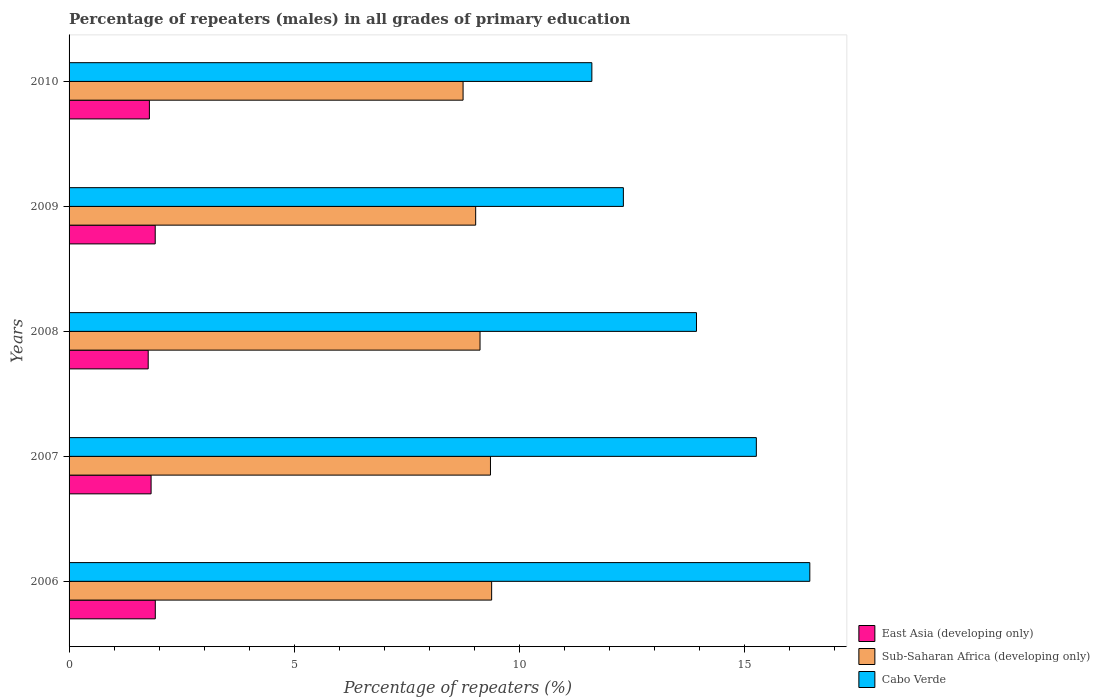How many different coloured bars are there?
Offer a very short reply. 3. How many groups of bars are there?
Your answer should be compact. 5. Are the number of bars per tick equal to the number of legend labels?
Make the answer very short. Yes. Are the number of bars on each tick of the Y-axis equal?
Give a very brief answer. Yes. How many bars are there on the 3rd tick from the top?
Give a very brief answer. 3. What is the percentage of repeaters (males) in Cabo Verde in 2009?
Provide a succinct answer. 12.31. Across all years, what is the maximum percentage of repeaters (males) in Sub-Saharan Africa (developing only)?
Keep it short and to the point. 9.38. Across all years, what is the minimum percentage of repeaters (males) in Sub-Saharan Africa (developing only)?
Give a very brief answer. 8.75. In which year was the percentage of repeaters (males) in Cabo Verde minimum?
Offer a terse response. 2010. What is the total percentage of repeaters (males) in East Asia (developing only) in the graph?
Offer a very short reply. 9.19. What is the difference between the percentage of repeaters (males) in Sub-Saharan Africa (developing only) in 2006 and that in 2007?
Ensure brevity in your answer.  0.03. What is the difference between the percentage of repeaters (males) in Sub-Saharan Africa (developing only) in 2006 and the percentage of repeaters (males) in Cabo Verde in 2007?
Your answer should be compact. -5.88. What is the average percentage of repeaters (males) in East Asia (developing only) per year?
Give a very brief answer. 1.84. In the year 2008, what is the difference between the percentage of repeaters (males) in East Asia (developing only) and percentage of repeaters (males) in Sub-Saharan Africa (developing only)?
Give a very brief answer. -7.37. What is the ratio of the percentage of repeaters (males) in Sub-Saharan Africa (developing only) in 2007 to that in 2008?
Provide a succinct answer. 1.03. Is the difference between the percentage of repeaters (males) in East Asia (developing only) in 2009 and 2010 greater than the difference between the percentage of repeaters (males) in Sub-Saharan Africa (developing only) in 2009 and 2010?
Your answer should be compact. No. What is the difference between the highest and the second highest percentage of repeaters (males) in Cabo Verde?
Your answer should be very brief. 1.19. What is the difference between the highest and the lowest percentage of repeaters (males) in Sub-Saharan Africa (developing only)?
Offer a terse response. 0.63. What does the 2nd bar from the top in 2010 represents?
Keep it short and to the point. Sub-Saharan Africa (developing only). What does the 2nd bar from the bottom in 2007 represents?
Your answer should be very brief. Sub-Saharan Africa (developing only). Are all the bars in the graph horizontal?
Offer a very short reply. Yes. What is the difference between two consecutive major ticks on the X-axis?
Offer a very short reply. 5. Does the graph contain any zero values?
Provide a short and direct response. No. Does the graph contain grids?
Keep it short and to the point. No. Where does the legend appear in the graph?
Offer a terse response. Bottom right. How are the legend labels stacked?
Offer a very short reply. Vertical. What is the title of the graph?
Provide a short and direct response. Percentage of repeaters (males) in all grades of primary education. What is the label or title of the X-axis?
Keep it short and to the point. Percentage of repeaters (%). What is the Percentage of repeaters (%) in East Asia (developing only) in 2006?
Provide a short and direct response. 1.91. What is the Percentage of repeaters (%) in Sub-Saharan Africa (developing only) in 2006?
Ensure brevity in your answer.  9.38. What is the Percentage of repeaters (%) of Cabo Verde in 2006?
Keep it short and to the point. 16.45. What is the Percentage of repeaters (%) of East Asia (developing only) in 2007?
Offer a terse response. 1.82. What is the Percentage of repeaters (%) of Sub-Saharan Africa (developing only) in 2007?
Your answer should be very brief. 9.36. What is the Percentage of repeaters (%) of Cabo Verde in 2007?
Give a very brief answer. 15.26. What is the Percentage of repeaters (%) of East Asia (developing only) in 2008?
Your answer should be very brief. 1.76. What is the Percentage of repeaters (%) in Sub-Saharan Africa (developing only) in 2008?
Provide a succinct answer. 9.12. What is the Percentage of repeaters (%) in Cabo Verde in 2008?
Provide a short and direct response. 13.93. What is the Percentage of repeaters (%) in East Asia (developing only) in 2009?
Offer a terse response. 1.91. What is the Percentage of repeaters (%) in Sub-Saharan Africa (developing only) in 2009?
Provide a succinct answer. 9.03. What is the Percentage of repeaters (%) of Cabo Verde in 2009?
Offer a terse response. 12.31. What is the Percentage of repeaters (%) of East Asia (developing only) in 2010?
Give a very brief answer. 1.78. What is the Percentage of repeaters (%) of Sub-Saharan Africa (developing only) in 2010?
Offer a very short reply. 8.75. What is the Percentage of repeaters (%) of Cabo Verde in 2010?
Offer a terse response. 11.61. Across all years, what is the maximum Percentage of repeaters (%) in East Asia (developing only)?
Your answer should be very brief. 1.91. Across all years, what is the maximum Percentage of repeaters (%) in Sub-Saharan Africa (developing only)?
Give a very brief answer. 9.38. Across all years, what is the maximum Percentage of repeaters (%) of Cabo Verde?
Provide a short and direct response. 16.45. Across all years, what is the minimum Percentage of repeaters (%) in East Asia (developing only)?
Provide a succinct answer. 1.76. Across all years, what is the minimum Percentage of repeaters (%) in Sub-Saharan Africa (developing only)?
Your answer should be compact. 8.75. Across all years, what is the minimum Percentage of repeaters (%) of Cabo Verde?
Your answer should be compact. 11.61. What is the total Percentage of repeaters (%) in East Asia (developing only) in the graph?
Offer a terse response. 9.19. What is the total Percentage of repeaters (%) in Sub-Saharan Africa (developing only) in the graph?
Your response must be concise. 45.64. What is the total Percentage of repeaters (%) of Cabo Verde in the graph?
Your response must be concise. 69.55. What is the difference between the Percentage of repeaters (%) of East Asia (developing only) in 2006 and that in 2007?
Offer a terse response. 0.09. What is the difference between the Percentage of repeaters (%) in Sub-Saharan Africa (developing only) in 2006 and that in 2007?
Offer a very short reply. 0.03. What is the difference between the Percentage of repeaters (%) in Cabo Verde in 2006 and that in 2007?
Make the answer very short. 1.19. What is the difference between the Percentage of repeaters (%) of East Asia (developing only) in 2006 and that in 2008?
Your answer should be very brief. 0.16. What is the difference between the Percentage of repeaters (%) in Sub-Saharan Africa (developing only) in 2006 and that in 2008?
Ensure brevity in your answer.  0.26. What is the difference between the Percentage of repeaters (%) of Cabo Verde in 2006 and that in 2008?
Make the answer very short. 2.52. What is the difference between the Percentage of repeaters (%) of East Asia (developing only) in 2006 and that in 2009?
Provide a short and direct response. 0. What is the difference between the Percentage of repeaters (%) in Sub-Saharan Africa (developing only) in 2006 and that in 2009?
Keep it short and to the point. 0.35. What is the difference between the Percentage of repeaters (%) of Cabo Verde in 2006 and that in 2009?
Offer a very short reply. 4.14. What is the difference between the Percentage of repeaters (%) in East Asia (developing only) in 2006 and that in 2010?
Provide a short and direct response. 0.13. What is the difference between the Percentage of repeaters (%) in Sub-Saharan Africa (developing only) in 2006 and that in 2010?
Keep it short and to the point. 0.63. What is the difference between the Percentage of repeaters (%) of Cabo Verde in 2006 and that in 2010?
Offer a very short reply. 4.84. What is the difference between the Percentage of repeaters (%) in East Asia (developing only) in 2007 and that in 2008?
Ensure brevity in your answer.  0.06. What is the difference between the Percentage of repeaters (%) of Sub-Saharan Africa (developing only) in 2007 and that in 2008?
Your answer should be very brief. 0.23. What is the difference between the Percentage of repeaters (%) of Cabo Verde in 2007 and that in 2008?
Keep it short and to the point. 1.33. What is the difference between the Percentage of repeaters (%) in East Asia (developing only) in 2007 and that in 2009?
Make the answer very short. -0.09. What is the difference between the Percentage of repeaters (%) in Sub-Saharan Africa (developing only) in 2007 and that in 2009?
Your answer should be very brief. 0.33. What is the difference between the Percentage of repeaters (%) of Cabo Verde in 2007 and that in 2009?
Your answer should be compact. 2.95. What is the difference between the Percentage of repeaters (%) of East Asia (developing only) in 2007 and that in 2010?
Your answer should be compact. 0.04. What is the difference between the Percentage of repeaters (%) of Sub-Saharan Africa (developing only) in 2007 and that in 2010?
Give a very brief answer. 0.61. What is the difference between the Percentage of repeaters (%) of Cabo Verde in 2007 and that in 2010?
Your response must be concise. 3.65. What is the difference between the Percentage of repeaters (%) of East Asia (developing only) in 2008 and that in 2009?
Give a very brief answer. -0.16. What is the difference between the Percentage of repeaters (%) of Sub-Saharan Africa (developing only) in 2008 and that in 2009?
Keep it short and to the point. 0.1. What is the difference between the Percentage of repeaters (%) of Cabo Verde in 2008 and that in 2009?
Ensure brevity in your answer.  1.62. What is the difference between the Percentage of repeaters (%) in East Asia (developing only) in 2008 and that in 2010?
Give a very brief answer. -0.03. What is the difference between the Percentage of repeaters (%) in Sub-Saharan Africa (developing only) in 2008 and that in 2010?
Offer a very short reply. 0.38. What is the difference between the Percentage of repeaters (%) in Cabo Verde in 2008 and that in 2010?
Offer a very short reply. 2.32. What is the difference between the Percentage of repeaters (%) of East Asia (developing only) in 2009 and that in 2010?
Your answer should be very brief. 0.13. What is the difference between the Percentage of repeaters (%) of Sub-Saharan Africa (developing only) in 2009 and that in 2010?
Offer a very short reply. 0.28. What is the difference between the Percentage of repeaters (%) of Cabo Verde in 2009 and that in 2010?
Your answer should be very brief. 0.7. What is the difference between the Percentage of repeaters (%) of East Asia (developing only) in 2006 and the Percentage of repeaters (%) of Sub-Saharan Africa (developing only) in 2007?
Offer a terse response. -7.44. What is the difference between the Percentage of repeaters (%) in East Asia (developing only) in 2006 and the Percentage of repeaters (%) in Cabo Verde in 2007?
Offer a terse response. -13.34. What is the difference between the Percentage of repeaters (%) in Sub-Saharan Africa (developing only) in 2006 and the Percentage of repeaters (%) in Cabo Verde in 2007?
Make the answer very short. -5.88. What is the difference between the Percentage of repeaters (%) of East Asia (developing only) in 2006 and the Percentage of repeaters (%) of Sub-Saharan Africa (developing only) in 2008?
Ensure brevity in your answer.  -7.21. What is the difference between the Percentage of repeaters (%) of East Asia (developing only) in 2006 and the Percentage of repeaters (%) of Cabo Verde in 2008?
Offer a terse response. -12.02. What is the difference between the Percentage of repeaters (%) in Sub-Saharan Africa (developing only) in 2006 and the Percentage of repeaters (%) in Cabo Verde in 2008?
Provide a short and direct response. -4.55. What is the difference between the Percentage of repeaters (%) of East Asia (developing only) in 2006 and the Percentage of repeaters (%) of Sub-Saharan Africa (developing only) in 2009?
Your response must be concise. -7.11. What is the difference between the Percentage of repeaters (%) in East Asia (developing only) in 2006 and the Percentage of repeaters (%) in Cabo Verde in 2009?
Offer a very short reply. -10.39. What is the difference between the Percentage of repeaters (%) of Sub-Saharan Africa (developing only) in 2006 and the Percentage of repeaters (%) of Cabo Verde in 2009?
Your answer should be very brief. -2.92. What is the difference between the Percentage of repeaters (%) in East Asia (developing only) in 2006 and the Percentage of repeaters (%) in Sub-Saharan Africa (developing only) in 2010?
Your answer should be very brief. -6.83. What is the difference between the Percentage of repeaters (%) in East Asia (developing only) in 2006 and the Percentage of repeaters (%) in Cabo Verde in 2010?
Give a very brief answer. -9.69. What is the difference between the Percentage of repeaters (%) of Sub-Saharan Africa (developing only) in 2006 and the Percentage of repeaters (%) of Cabo Verde in 2010?
Offer a terse response. -2.23. What is the difference between the Percentage of repeaters (%) in East Asia (developing only) in 2007 and the Percentage of repeaters (%) in Sub-Saharan Africa (developing only) in 2008?
Provide a succinct answer. -7.3. What is the difference between the Percentage of repeaters (%) of East Asia (developing only) in 2007 and the Percentage of repeaters (%) of Cabo Verde in 2008?
Make the answer very short. -12.11. What is the difference between the Percentage of repeaters (%) in Sub-Saharan Africa (developing only) in 2007 and the Percentage of repeaters (%) in Cabo Verde in 2008?
Provide a short and direct response. -4.57. What is the difference between the Percentage of repeaters (%) in East Asia (developing only) in 2007 and the Percentage of repeaters (%) in Sub-Saharan Africa (developing only) in 2009?
Your answer should be compact. -7.21. What is the difference between the Percentage of repeaters (%) in East Asia (developing only) in 2007 and the Percentage of repeaters (%) in Cabo Verde in 2009?
Make the answer very short. -10.49. What is the difference between the Percentage of repeaters (%) in Sub-Saharan Africa (developing only) in 2007 and the Percentage of repeaters (%) in Cabo Verde in 2009?
Give a very brief answer. -2.95. What is the difference between the Percentage of repeaters (%) of East Asia (developing only) in 2007 and the Percentage of repeaters (%) of Sub-Saharan Africa (developing only) in 2010?
Keep it short and to the point. -6.93. What is the difference between the Percentage of repeaters (%) of East Asia (developing only) in 2007 and the Percentage of repeaters (%) of Cabo Verde in 2010?
Offer a very short reply. -9.79. What is the difference between the Percentage of repeaters (%) of Sub-Saharan Africa (developing only) in 2007 and the Percentage of repeaters (%) of Cabo Verde in 2010?
Provide a short and direct response. -2.25. What is the difference between the Percentage of repeaters (%) in East Asia (developing only) in 2008 and the Percentage of repeaters (%) in Sub-Saharan Africa (developing only) in 2009?
Give a very brief answer. -7.27. What is the difference between the Percentage of repeaters (%) in East Asia (developing only) in 2008 and the Percentage of repeaters (%) in Cabo Verde in 2009?
Provide a succinct answer. -10.55. What is the difference between the Percentage of repeaters (%) in Sub-Saharan Africa (developing only) in 2008 and the Percentage of repeaters (%) in Cabo Verde in 2009?
Give a very brief answer. -3.18. What is the difference between the Percentage of repeaters (%) of East Asia (developing only) in 2008 and the Percentage of repeaters (%) of Sub-Saharan Africa (developing only) in 2010?
Give a very brief answer. -6.99. What is the difference between the Percentage of repeaters (%) in East Asia (developing only) in 2008 and the Percentage of repeaters (%) in Cabo Verde in 2010?
Give a very brief answer. -9.85. What is the difference between the Percentage of repeaters (%) of Sub-Saharan Africa (developing only) in 2008 and the Percentage of repeaters (%) of Cabo Verde in 2010?
Make the answer very short. -2.48. What is the difference between the Percentage of repeaters (%) of East Asia (developing only) in 2009 and the Percentage of repeaters (%) of Sub-Saharan Africa (developing only) in 2010?
Offer a very short reply. -6.84. What is the difference between the Percentage of repeaters (%) of East Asia (developing only) in 2009 and the Percentage of repeaters (%) of Cabo Verde in 2010?
Provide a short and direct response. -9.69. What is the difference between the Percentage of repeaters (%) of Sub-Saharan Africa (developing only) in 2009 and the Percentage of repeaters (%) of Cabo Verde in 2010?
Your response must be concise. -2.58. What is the average Percentage of repeaters (%) of East Asia (developing only) per year?
Offer a very short reply. 1.84. What is the average Percentage of repeaters (%) in Sub-Saharan Africa (developing only) per year?
Offer a very short reply. 9.13. What is the average Percentage of repeaters (%) of Cabo Verde per year?
Your answer should be very brief. 13.91. In the year 2006, what is the difference between the Percentage of repeaters (%) in East Asia (developing only) and Percentage of repeaters (%) in Sub-Saharan Africa (developing only)?
Make the answer very short. -7.47. In the year 2006, what is the difference between the Percentage of repeaters (%) in East Asia (developing only) and Percentage of repeaters (%) in Cabo Verde?
Give a very brief answer. -14.53. In the year 2006, what is the difference between the Percentage of repeaters (%) of Sub-Saharan Africa (developing only) and Percentage of repeaters (%) of Cabo Verde?
Make the answer very short. -7.06. In the year 2007, what is the difference between the Percentage of repeaters (%) in East Asia (developing only) and Percentage of repeaters (%) in Sub-Saharan Africa (developing only)?
Make the answer very short. -7.54. In the year 2007, what is the difference between the Percentage of repeaters (%) of East Asia (developing only) and Percentage of repeaters (%) of Cabo Verde?
Your answer should be compact. -13.44. In the year 2007, what is the difference between the Percentage of repeaters (%) of Sub-Saharan Africa (developing only) and Percentage of repeaters (%) of Cabo Verde?
Give a very brief answer. -5.9. In the year 2008, what is the difference between the Percentage of repeaters (%) in East Asia (developing only) and Percentage of repeaters (%) in Sub-Saharan Africa (developing only)?
Your answer should be very brief. -7.37. In the year 2008, what is the difference between the Percentage of repeaters (%) in East Asia (developing only) and Percentage of repeaters (%) in Cabo Verde?
Your response must be concise. -12.17. In the year 2008, what is the difference between the Percentage of repeaters (%) in Sub-Saharan Africa (developing only) and Percentage of repeaters (%) in Cabo Verde?
Your answer should be very brief. -4.81. In the year 2009, what is the difference between the Percentage of repeaters (%) of East Asia (developing only) and Percentage of repeaters (%) of Sub-Saharan Africa (developing only)?
Offer a terse response. -7.12. In the year 2009, what is the difference between the Percentage of repeaters (%) of East Asia (developing only) and Percentage of repeaters (%) of Cabo Verde?
Your response must be concise. -10.39. In the year 2009, what is the difference between the Percentage of repeaters (%) of Sub-Saharan Africa (developing only) and Percentage of repeaters (%) of Cabo Verde?
Offer a terse response. -3.28. In the year 2010, what is the difference between the Percentage of repeaters (%) in East Asia (developing only) and Percentage of repeaters (%) in Sub-Saharan Africa (developing only)?
Provide a succinct answer. -6.96. In the year 2010, what is the difference between the Percentage of repeaters (%) in East Asia (developing only) and Percentage of repeaters (%) in Cabo Verde?
Your answer should be very brief. -9.82. In the year 2010, what is the difference between the Percentage of repeaters (%) of Sub-Saharan Africa (developing only) and Percentage of repeaters (%) of Cabo Verde?
Your answer should be very brief. -2.86. What is the ratio of the Percentage of repeaters (%) of East Asia (developing only) in 2006 to that in 2007?
Offer a very short reply. 1.05. What is the ratio of the Percentage of repeaters (%) in Cabo Verde in 2006 to that in 2007?
Provide a short and direct response. 1.08. What is the ratio of the Percentage of repeaters (%) in East Asia (developing only) in 2006 to that in 2008?
Provide a succinct answer. 1.09. What is the ratio of the Percentage of repeaters (%) in Sub-Saharan Africa (developing only) in 2006 to that in 2008?
Provide a succinct answer. 1.03. What is the ratio of the Percentage of repeaters (%) in Cabo Verde in 2006 to that in 2008?
Your response must be concise. 1.18. What is the ratio of the Percentage of repeaters (%) of East Asia (developing only) in 2006 to that in 2009?
Provide a short and direct response. 1. What is the ratio of the Percentage of repeaters (%) of Sub-Saharan Africa (developing only) in 2006 to that in 2009?
Offer a terse response. 1.04. What is the ratio of the Percentage of repeaters (%) in Cabo Verde in 2006 to that in 2009?
Give a very brief answer. 1.34. What is the ratio of the Percentage of repeaters (%) of East Asia (developing only) in 2006 to that in 2010?
Offer a very short reply. 1.07. What is the ratio of the Percentage of repeaters (%) in Sub-Saharan Africa (developing only) in 2006 to that in 2010?
Keep it short and to the point. 1.07. What is the ratio of the Percentage of repeaters (%) of Cabo Verde in 2006 to that in 2010?
Offer a terse response. 1.42. What is the ratio of the Percentage of repeaters (%) in East Asia (developing only) in 2007 to that in 2008?
Offer a very short reply. 1.04. What is the ratio of the Percentage of repeaters (%) in Sub-Saharan Africa (developing only) in 2007 to that in 2008?
Your response must be concise. 1.03. What is the ratio of the Percentage of repeaters (%) in Cabo Verde in 2007 to that in 2008?
Keep it short and to the point. 1.1. What is the ratio of the Percentage of repeaters (%) in East Asia (developing only) in 2007 to that in 2009?
Ensure brevity in your answer.  0.95. What is the ratio of the Percentage of repeaters (%) in Sub-Saharan Africa (developing only) in 2007 to that in 2009?
Your response must be concise. 1.04. What is the ratio of the Percentage of repeaters (%) of Cabo Verde in 2007 to that in 2009?
Keep it short and to the point. 1.24. What is the ratio of the Percentage of repeaters (%) of Sub-Saharan Africa (developing only) in 2007 to that in 2010?
Offer a very short reply. 1.07. What is the ratio of the Percentage of repeaters (%) in Cabo Verde in 2007 to that in 2010?
Make the answer very short. 1.31. What is the ratio of the Percentage of repeaters (%) in East Asia (developing only) in 2008 to that in 2009?
Give a very brief answer. 0.92. What is the ratio of the Percentage of repeaters (%) in Sub-Saharan Africa (developing only) in 2008 to that in 2009?
Provide a short and direct response. 1.01. What is the ratio of the Percentage of repeaters (%) of Cabo Verde in 2008 to that in 2009?
Make the answer very short. 1.13. What is the ratio of the Percentage of repeaters (%) in East Asia (developing only) in 2008 to that in 2010?
Ensure brevity in your answer.  0.99. What is the ratio of the Percentage of repeaters (%) of Sub-Saharan Africa (developing only) in 2008 to that in 2010?
Keep it short and to the point. 1.04. What is the ratio of the Percentage of repeaters (%) of Cabo Verde in 2008 to that in 2010?
Your answer should be compact. 1.2. What is the ratio of the Percentage of repeaters (%) in East Asia (developing only) in 2009 to that in 2010?
Your answer should be very brief. 1.07. What is the ratio of the Percentage of repeaters (%) of Sub-Saharan Africa (developing only) in 2009 to that in 2010?
Provide a succinct answer. 1.03. What is the ratio of the Percentage of repeaters (%) of Cabo Verde in 2009 to that in 2010?
Ensure brevity in your answer.  1.06. What is the difference between the highest and the second highest Percentage of repeaters (%) in East Asia (developing only)?
Make the answer very short. 0. What is the difference between the highest and the second highest Percentage of repeaters (%) in Sub-Saharan Africa (developing only)?
Your answer should be very brief. 0.03. What is the difference between the highest and the second highest Percentage of repeaters (%) of Cabo Verde?
Ensure brevity in your answer.  1.19. What is the difference between the highest and the lowest Percentage of repeaters (%) of East Asia (developing only)?
Your response must be concise. 0.16. What is the difference between the highest and the lowest Percentage of repeaters (%) of Sub-Saharan Africa (developing only)?
Make the answer very short. 0.63. What is the difference between the highest and the lowest Percentage of repeaters (%) in Cabo Verde?
Your answer should be compact. 4.84. 